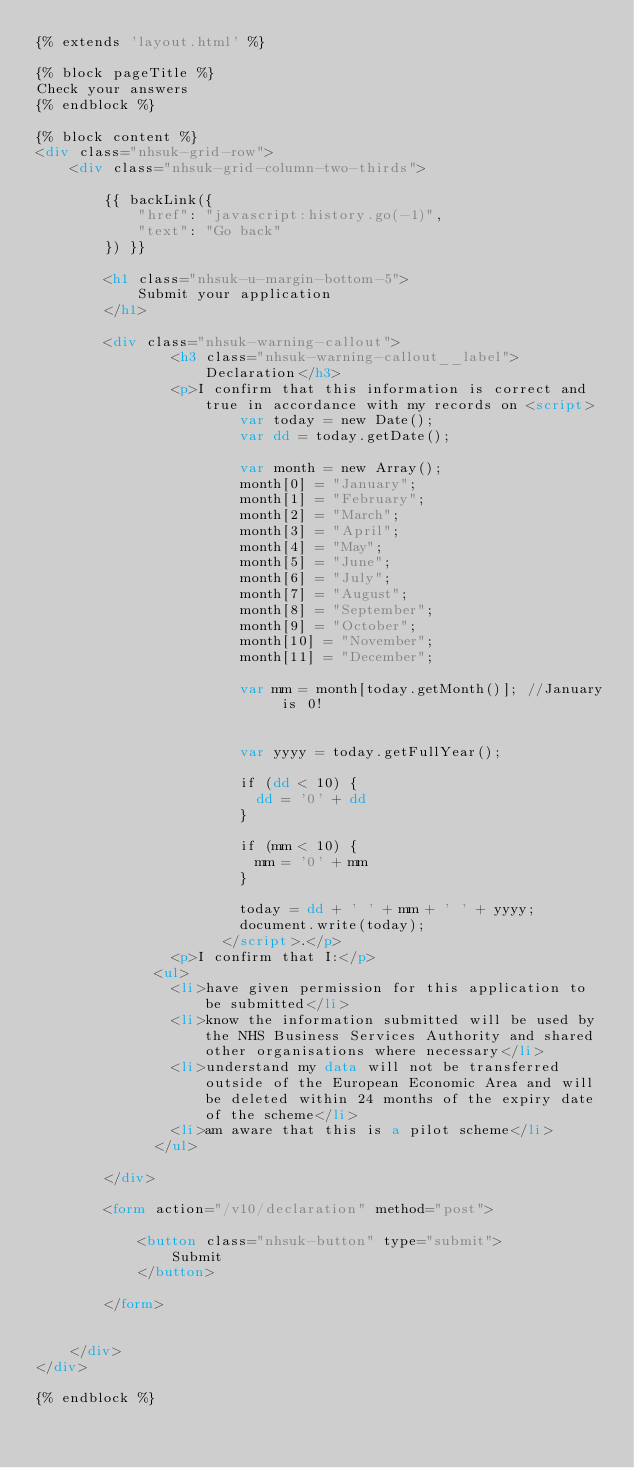Convert code to text. <code><loc_0><loc_0><loc_500><loc_500><_HTML_>{% extends 'layout.html' %}

{% block pageTitle %}
Check your answers
{% endblock %}

{% block content %}
<div class="nhsuk-grid-row">
    <div class="nhsuk-grid-column-two-thirds">

        {{ backLink({
            "href": "javascript:history.go(-1)",
            "text": "Go back"
        }) }}

        <h1 class="nhsuk-u-margin-bottom-5">
            Submit your application
        </h1>

        <div class="nhsuk-warning-callout">
                <h3 class="nhsuk-warning-callout__label">Declaration</h3>
                <p>I confirm that this information is correct and true in accordance with my records on <script>
                        var today = new Date();
                        var dd = today.getDate();
        
                        var month = new Array();
                        month[0] = "January";
                        month[1] = "February";
                        month[2] = "March";
                        month[3] = "April";
                        month[4] = "May";
                        month[5] = "June";
                        month[6] = "July";
                        month[7] = "August";
                        month[8] = "September";
                        month[9] = "October";
                        month[10] = "November";
                        month[11] = "December";
        
                        var mm = month[today.getMonth()]; //January is 0!
        
        
                        var yyyy = today.getFullYear();
        
                        if (dd < 10) {
                          dd = '0' + dd
                        }
        
                        if (mm < 10) {
                          mm = '0' + mm
                        }
        
                        today = dd + ' ' + mm + ' ' + yyyy;
                        document.write(today);
                      </script>.</p>
                <p>I confirm that I:</p>
              <ul>
                <li>have given permission for this application to be submitted</li>
                <li>know the information submitted will be used by the NHS Business Services Authority and shared other organisations where necessary</li>
                <li>understand my data will not be transferred outside of the European Economic Area and will be deleted within 24 months of the expiry date of the scheme</li>
                <li>am aware that this is a pilot scheme</li>
              </ul>
              
        </div>

        <form action="/v10/declaration" method="post">

            <button class="nhsuk-button" type="submit">
                Submit
            </button>

        </form>


    </div>
</div>

{% endblock %}</code> 